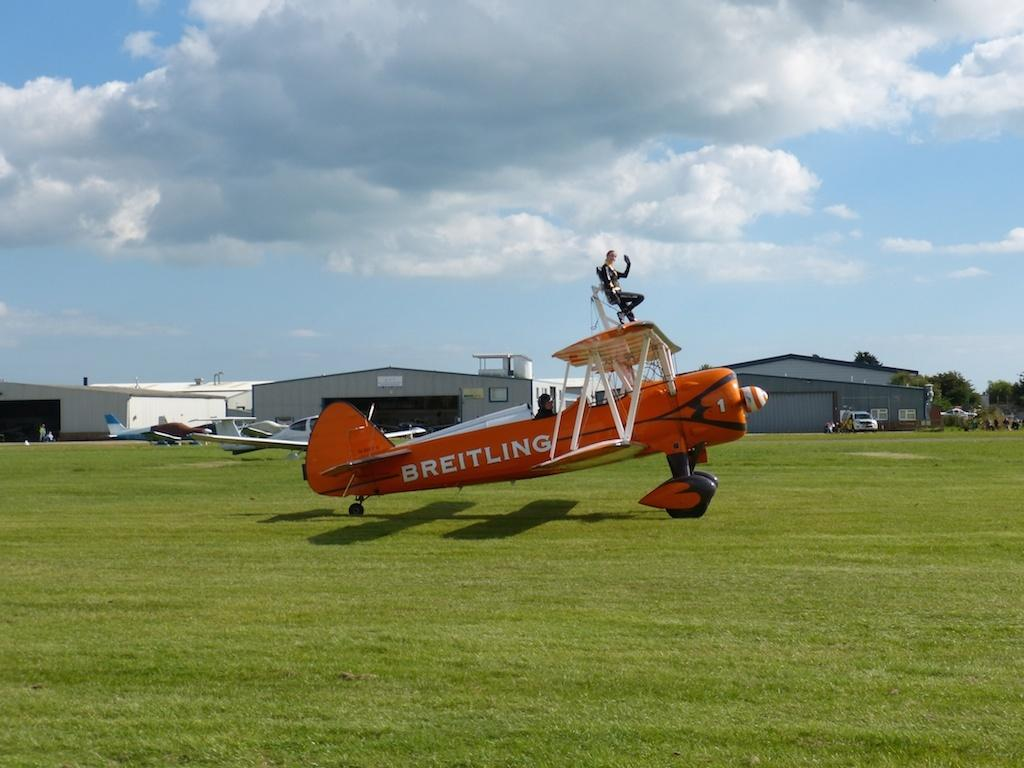Provide a one-sentence caption for the provided image. An orange plane that is owned by the company Breitling. 